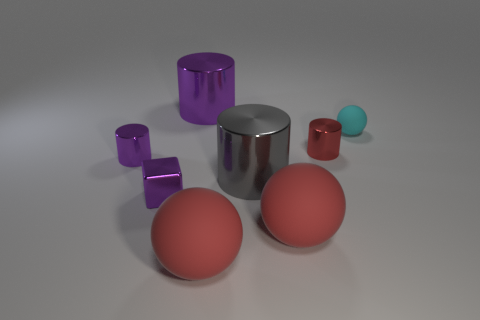There is a tiny sphere; is it the same color as the small metal cylinder that is on the right side of the purple metal block?
Your answer should be compact. No. The large metallic thing that is behind the small metallic cylinder that is right of the small purple metallic object that is in front of the gray object is what color?
Your answer should be compact. Purple. There is another large object that is the same shape as the big gray metal object; what is its color?
Provide a succinct answer. Purple. Are there an equal number of red objects behind the tiny red cylinder and green metallic cubes?
Your response must be concise. Yes. What number of blocks are big objects or large matte things?
Your answer should be very brief. 0. There is a small block that is the same material as the red cylinder; what color is it?
Offer a terse response. Purple. Do the big purple object and the big cylinder in front of the small matte object have the same material?
Your answer should be very brief. Yes. What number of things are red metal objects or big purple shiny objects?
Your response must be concise. 2. There is a tiny thing that is the same color as the tiny block; what is it made of?
Keep it short and to the point. Metal. Are there any red matte objects that have the same shape as the cyan thing?
Provide a succinct answer. Yes. 